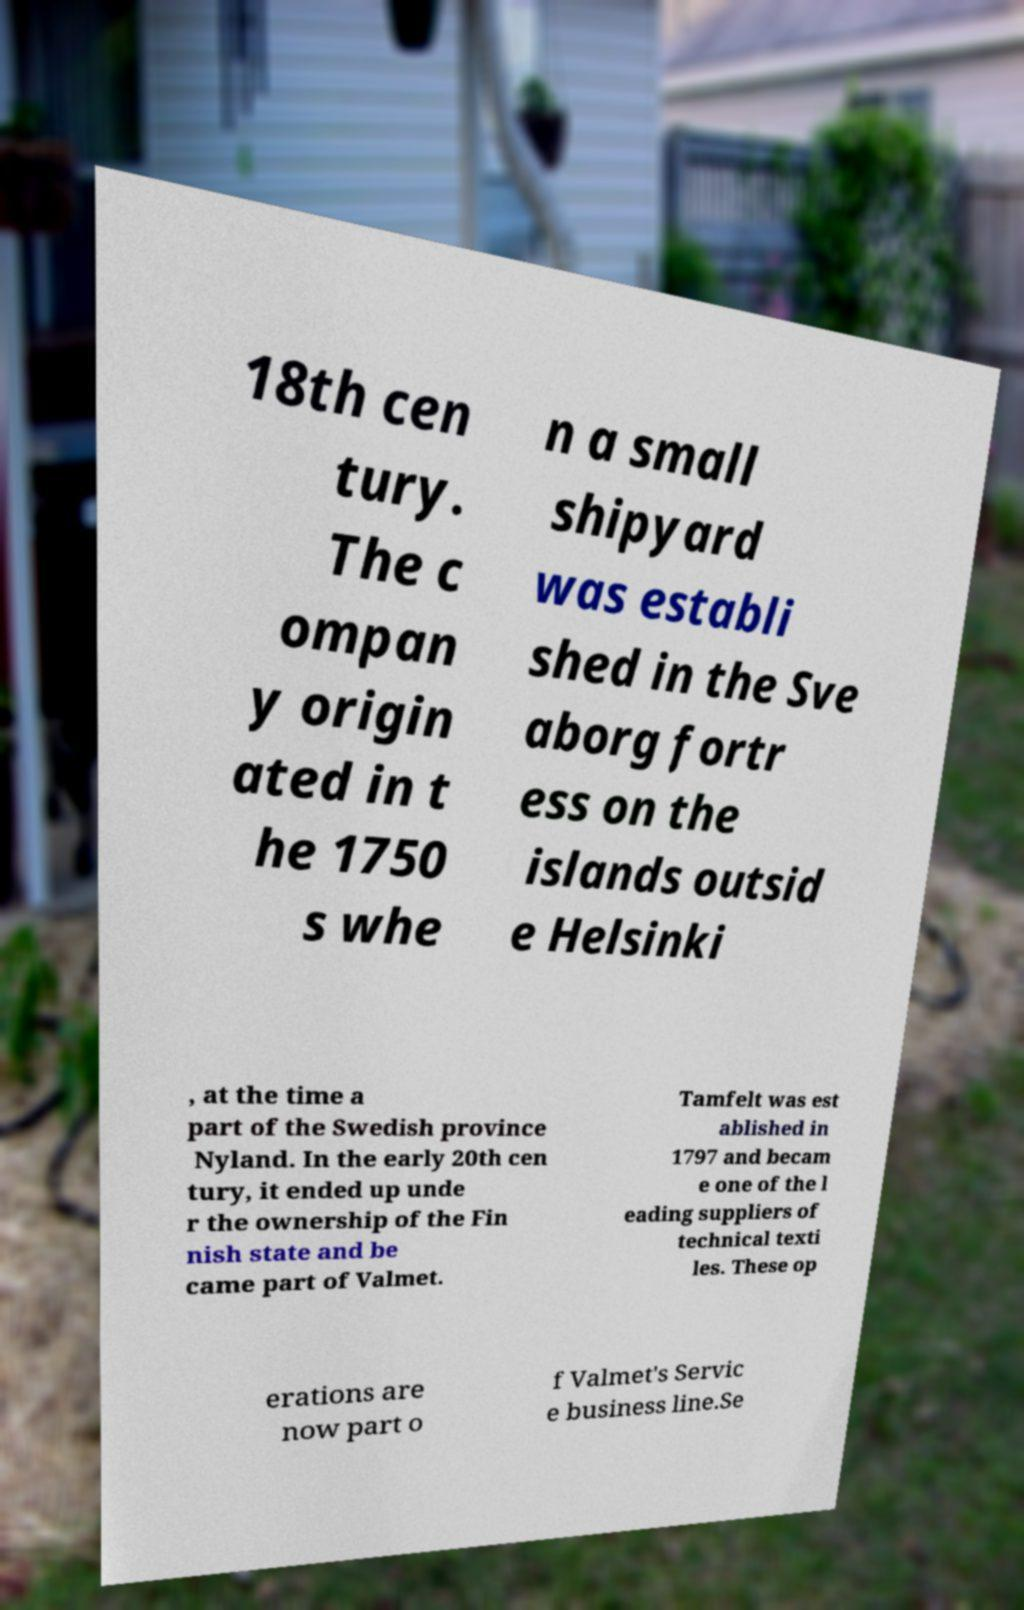There's text embedded in this image that I need extracted. Can you transcribe it verbatim? 18th cen tury. The c ompan y origin ated in t he 1750 s whe n a small shipyard was establi shed in the Sve aborg fortr ess on the islands outsid e Helsinki , at the time a part of the Swedish province Nyland. In the early 20th cen tury, it ended up unde r the ownership of the Fin nish state and be came part of Valmet. Tamfelt was est ablished in 1797 and becam e one of the l eading suppliers of technical texti les. These op erations are now part o f Valmet's Servic e business line.Se 